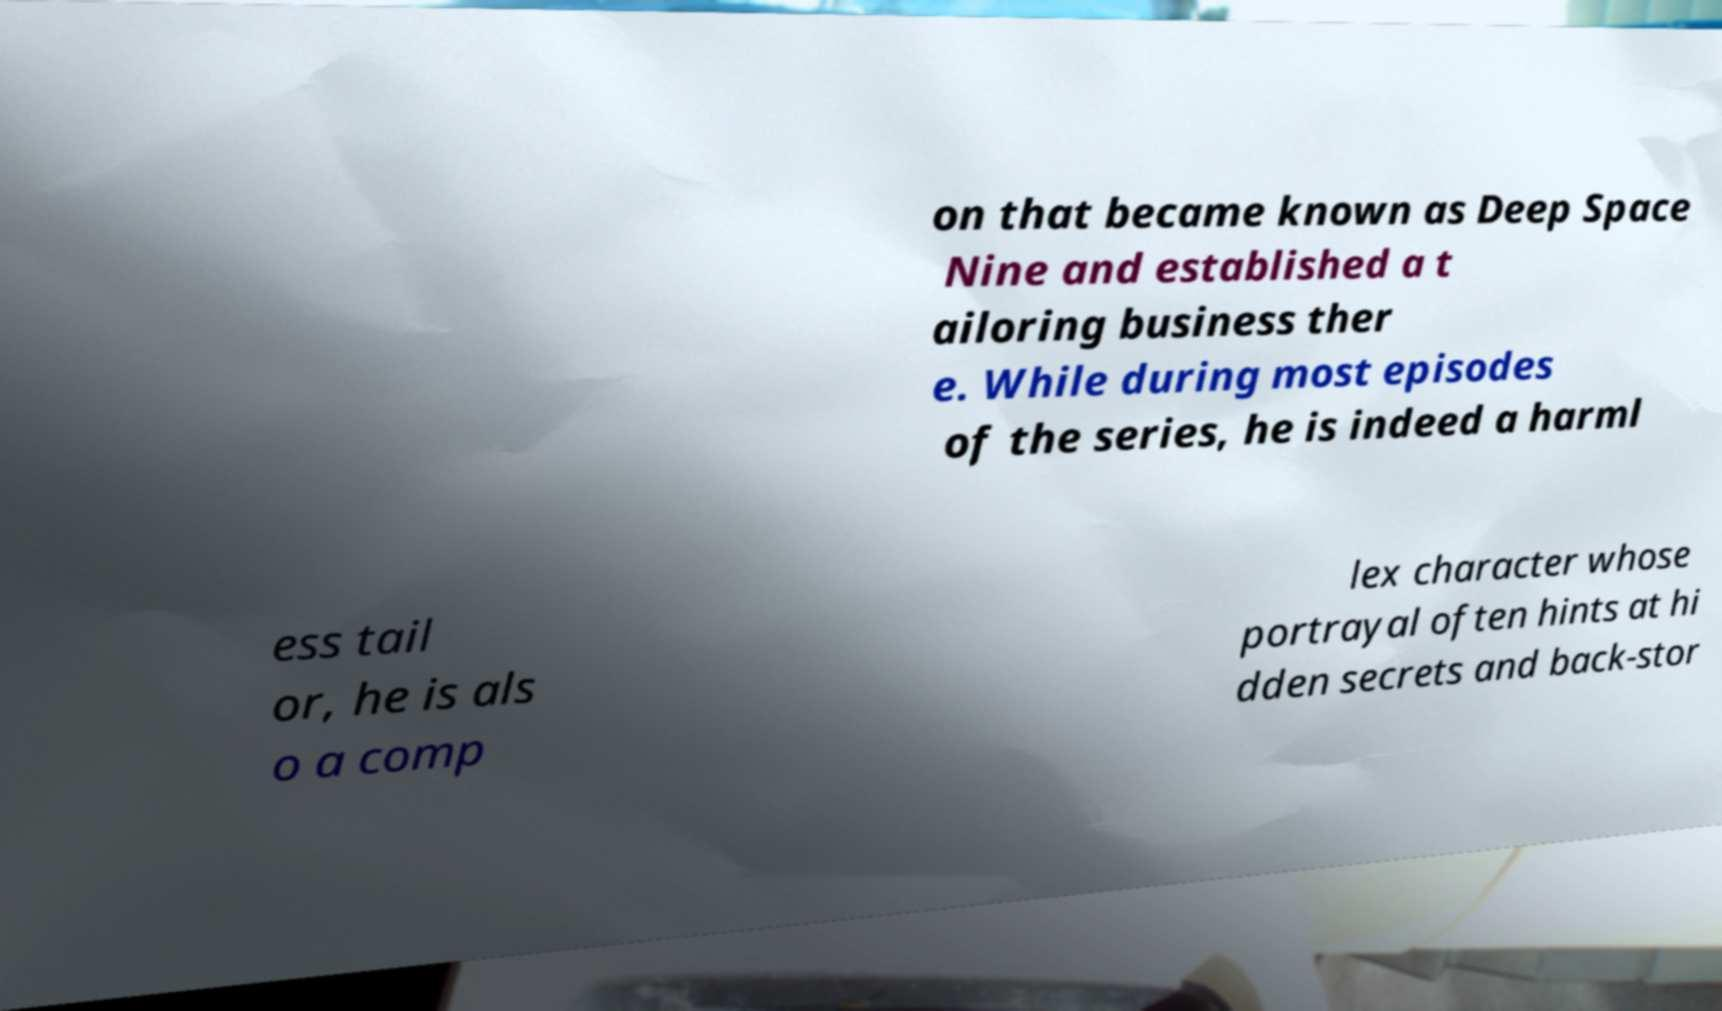What messages or text are displayed in this image? I need them in a readable, typed format. on that became known as Deep Space Nine and established a t ailoring business ther e. While during most episodes of the series, he is indeed a harml ess tail or, he is als o a comp lex character whose portrayal often hints at hi dden secrets and back-stor 